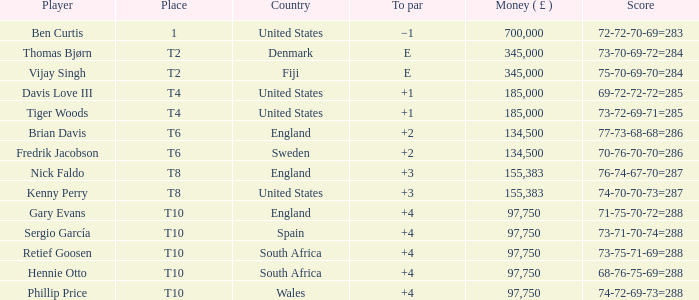What is the Place of Davis Love III with a To Par of +1? T4. 